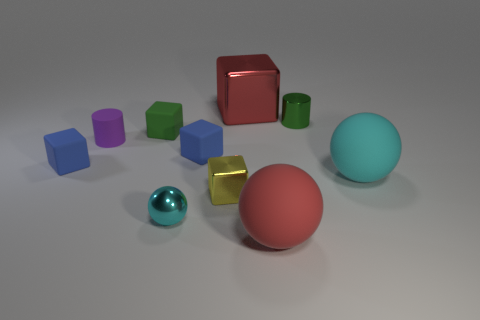Is the color of the rubber cylinder the same as the small metallic cylinder?
Offer a very short reply. No. There is a big metal object; what shape is it?
Offer a very short reply. Cube. Are there any large matte things that have the same color as the rubber cylinder?
Offer a very short reply. No. Are there more small cyan metal objects that are behind the yellow object than tiny blue rubber cylinders?
Provide a short and direct response. No. Does the small green metal thing have the same shape as the purple rubber thing that is left of the green cylinder?
Offer a terse response. Yes. Are there any cyan matte spheres?
Your response must be concise. Yes. How many tiny things are either purple rubber things or cyan matte objects?
Provide a short and direct response. 1. Is the number of blue cubes behind the big metallic block greater than the number of green metal objects that are to the right of the small metallic cylinder?
Ensure brevity in your answer.  No. Does the purple object have the same material as the cylinder that is to the right of the large red shiny thing?
Give a very brief answer. No. What is the color of the tiny rubber cylinder?
Provide a short and direct response. Purple. 